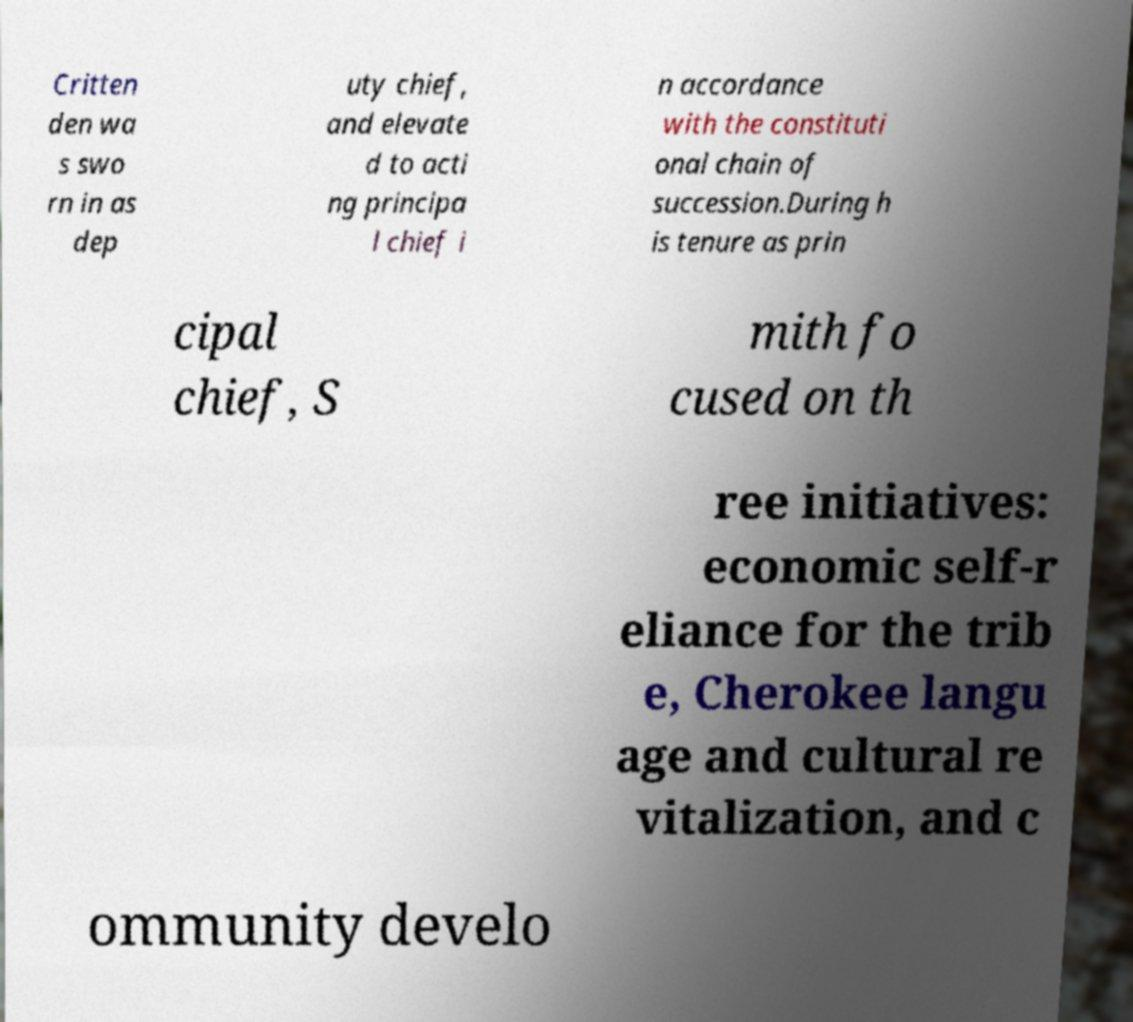Can you read and provide the text displayed in the image?This photo seems to have some interesting text. Can you extract and type it out for me? Critten den wa s swo rn in as dep uty chief, and elevate d to acti ng principa l chief i n accordance with the constituti onal chain of succession.During h is tenure as prin cipal chief, S mith fo cused on th ree initiatives: economic self-r eliance for the trib e, Cherokee langu age and cultural re vitalization, and c ommunity develo 